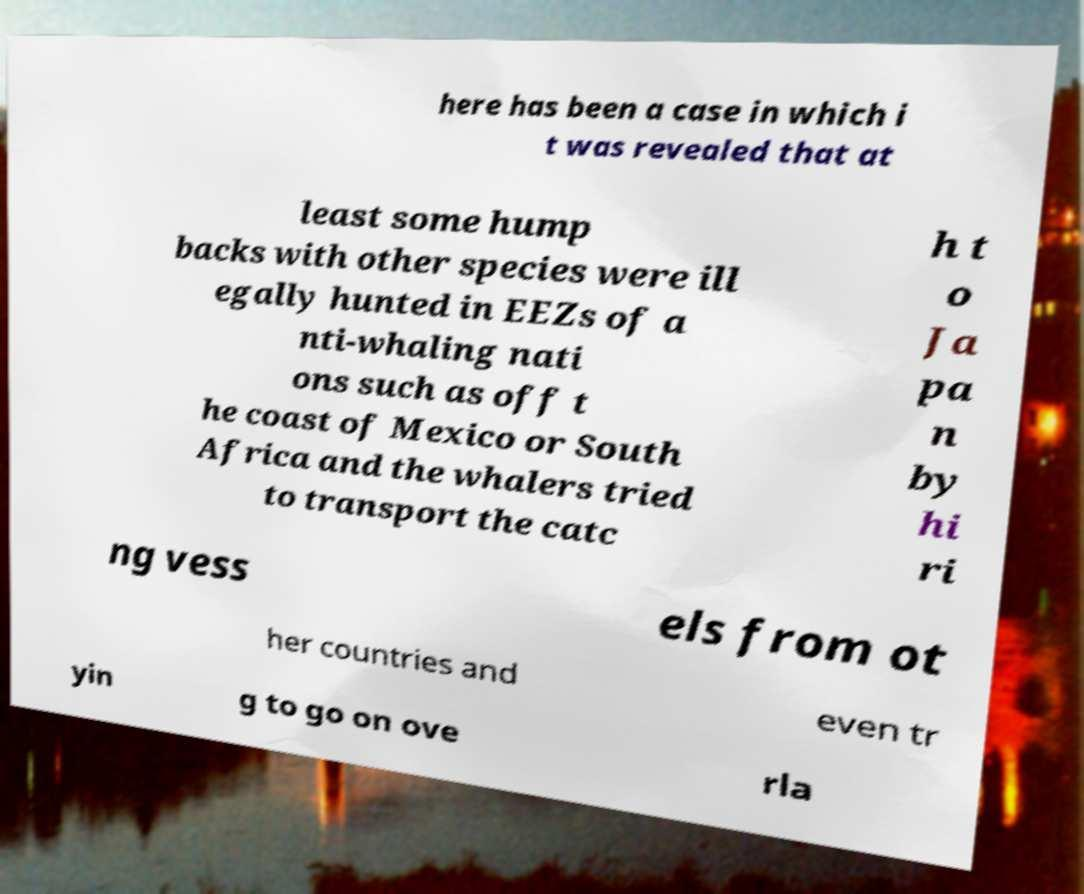Please identify and transcribe the text found in this image. here has been a case in which i t was revealed that at least some hump backs with other species were ill egally hunted in EEZs of a nti-whaling nati ons such as off t he coast of Mexico or South Africa and the whalers tried to transport the catc h t o Ja pa n by hi ri ng vess els from ot her countries and even tr yin g to go on ove rla 